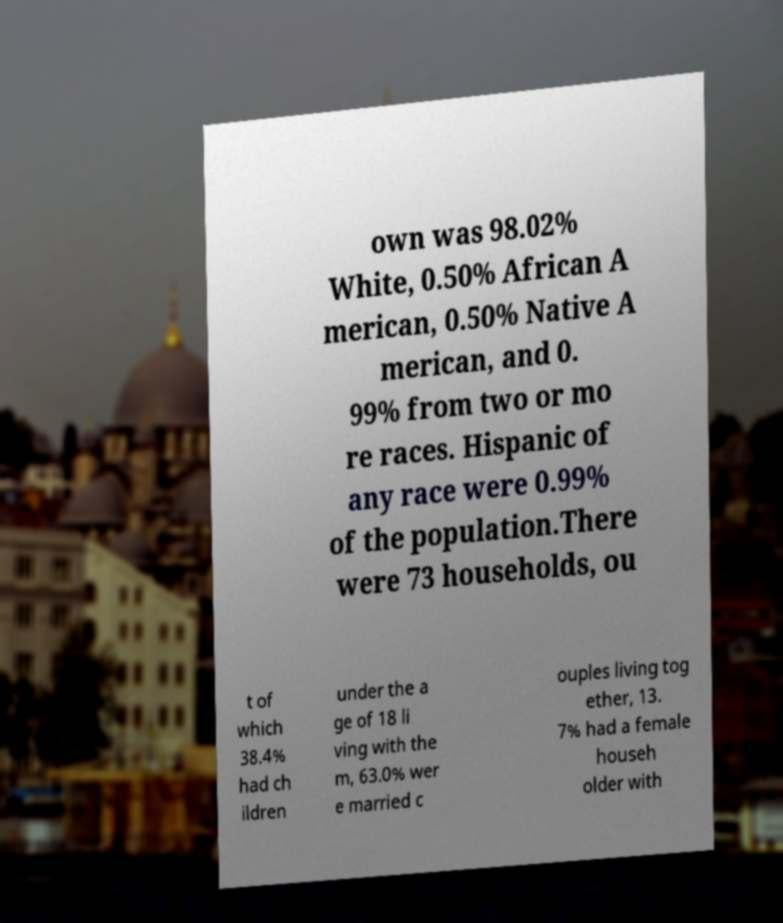I need the written content from this picture converted into text. Can you do that? own was 98.02% White, 0.50% African A merican, 0.50% Native A merican, and 0. 99% from two or mo re races. Hispanic of any race were 0.99% of the population.There were 73 households, ou t of which 38.4% had ch ildren under the a ge of 18 li ving with the m, 63.0% wer e married c ouples living tog ether, 13. 7% had a female househ older with 